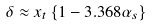<formula> <loc_0><loc_0><loc_500><loc_500>\delta \approx x _ { t } \left \{ 1 - 3 . 3 6 8 \alpha _ { s } \right \}</formula> 